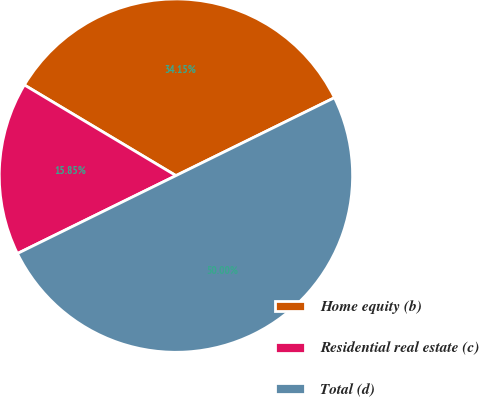<chart> <loc_0><loc_0><loc_500><loc_500><pie_chart><fcel>Home equity (b)<fcel>Residential real estate (c)<fcel>Total (d)<nl><fcel>34.15%<fcel>15.85%<fcel>50.0%<nl></chart> 